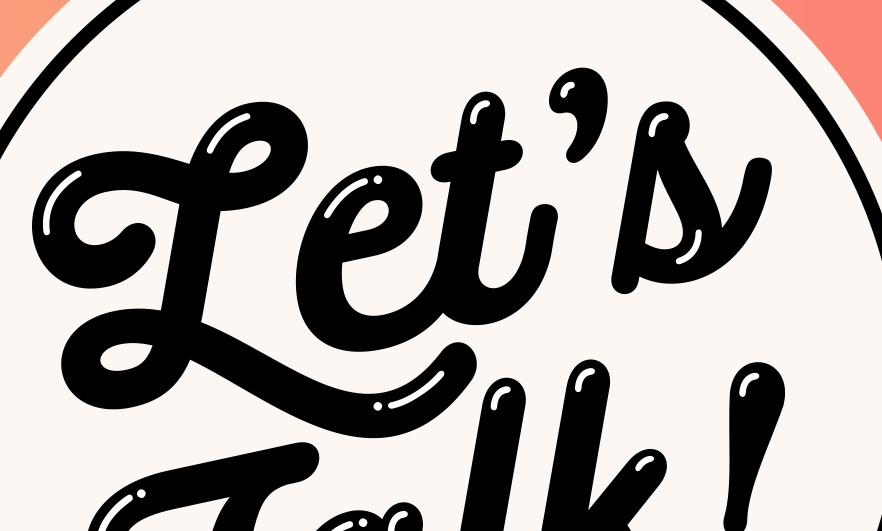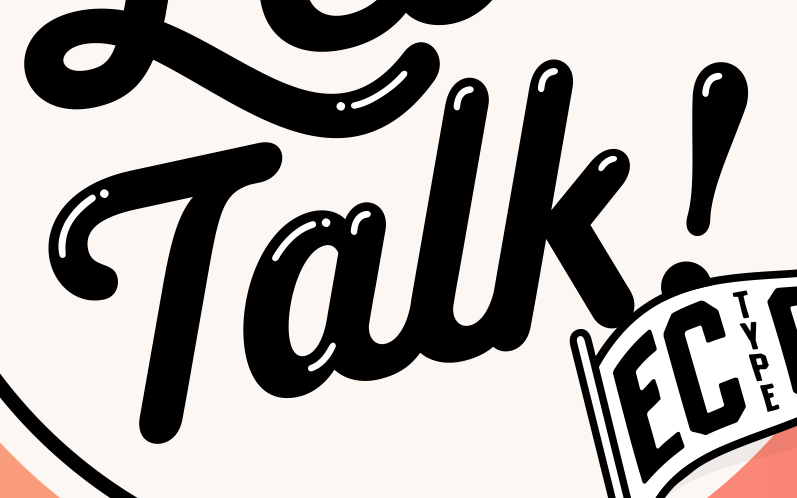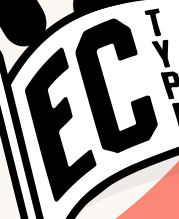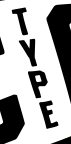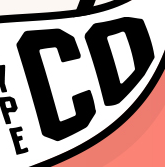Identify the words shown in these images in order, separated by a semicolon. Let's; Talk!; EC; TYPE; CD 